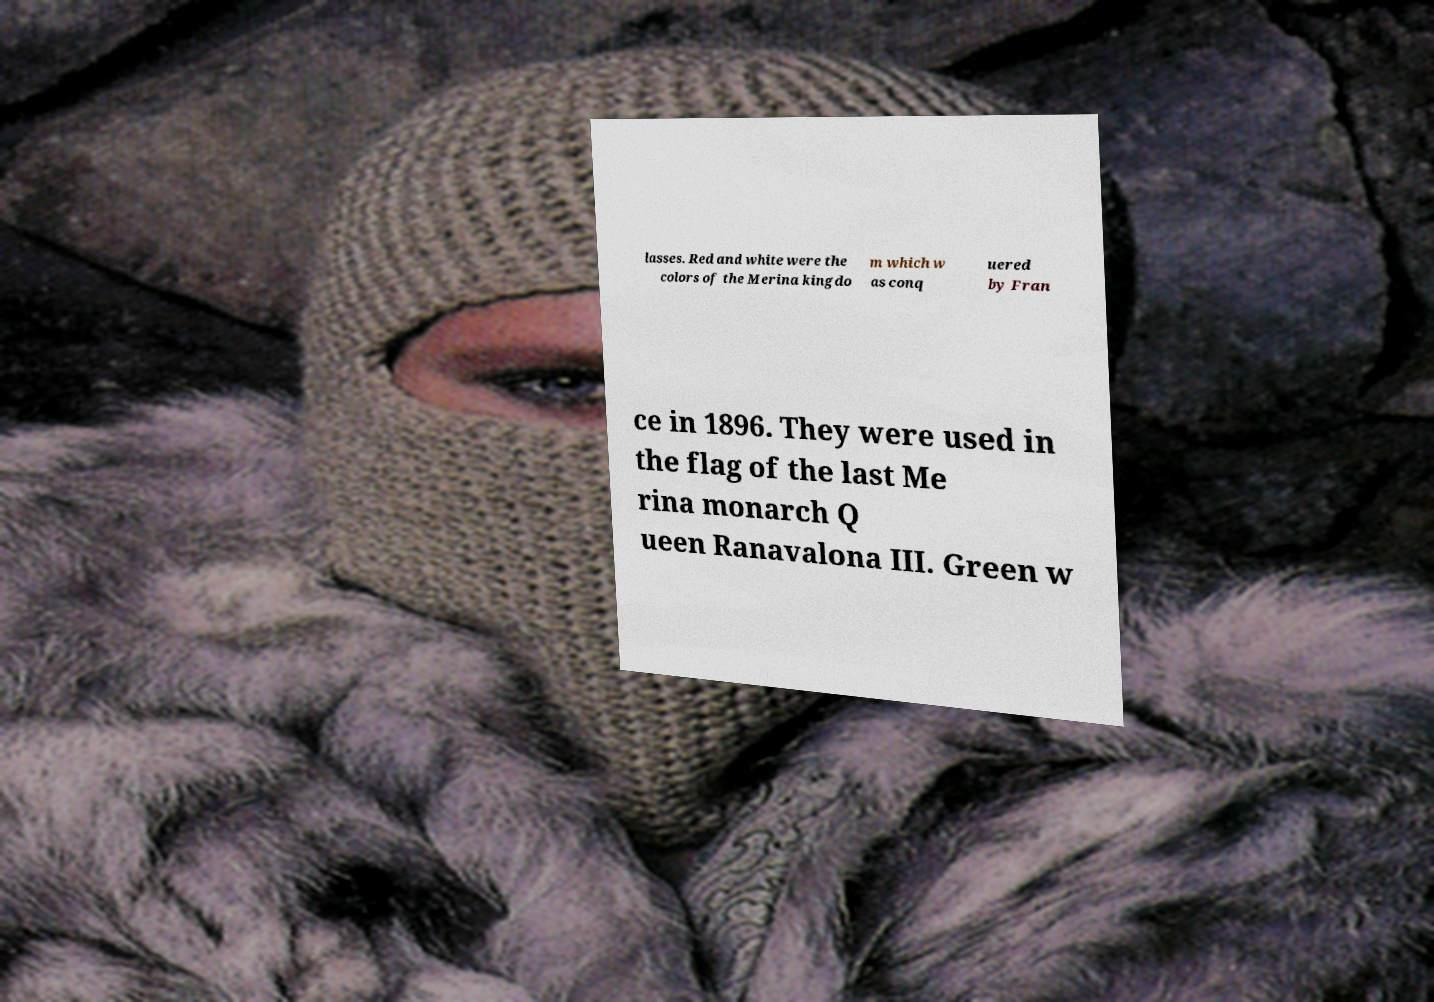Can you read and provide the text displayed in the image?This photo seems to have some interesting text. Can you extract and type it out for me? lasses. Red and white were the colors of the Merina kingdo m which w as conq uered by Fran ce in 1896. They were used in the flag of the last Me rina monarch Q ueen Ranavalona III. Green w 